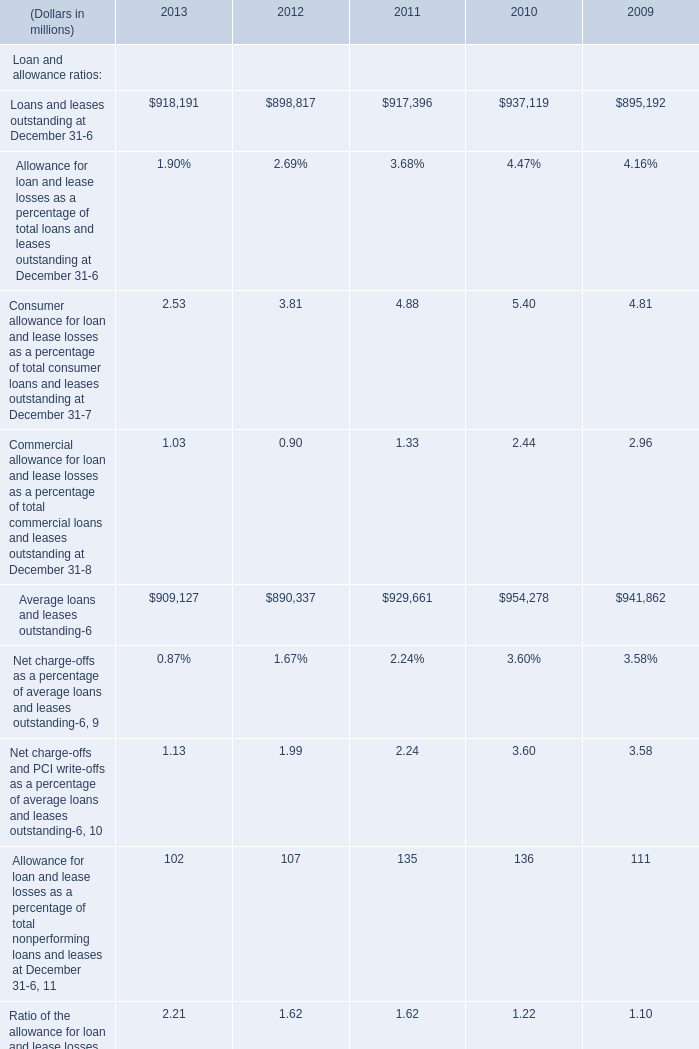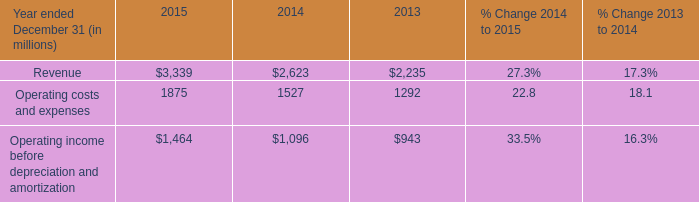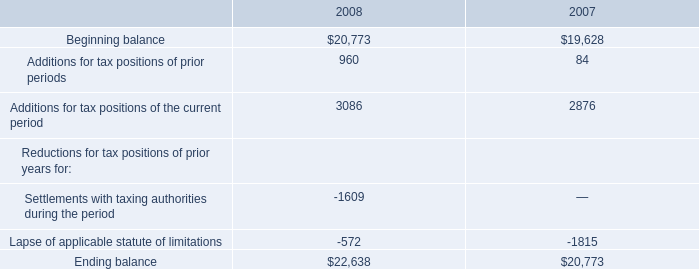what's the total amount of Loans and leases outstanding at December 31 of 2010, and Beginning balance of 2008 ? 
Computations: (937119.0 + 20773.0)
Answer: 957892.0. 